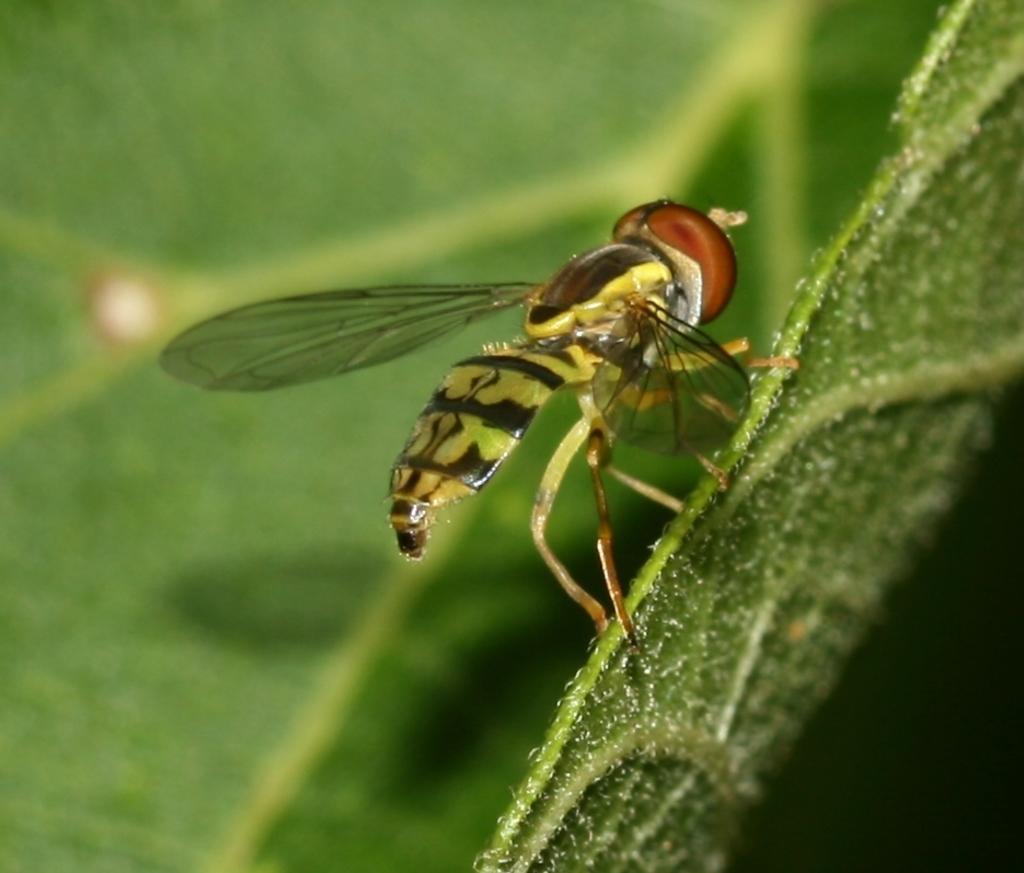How would you summarize this image in a sentence or two? This image is taken outdoors. In the background there is a leaf. The leaf is green in color. In the middle of the image there is a fly on the leaf. 